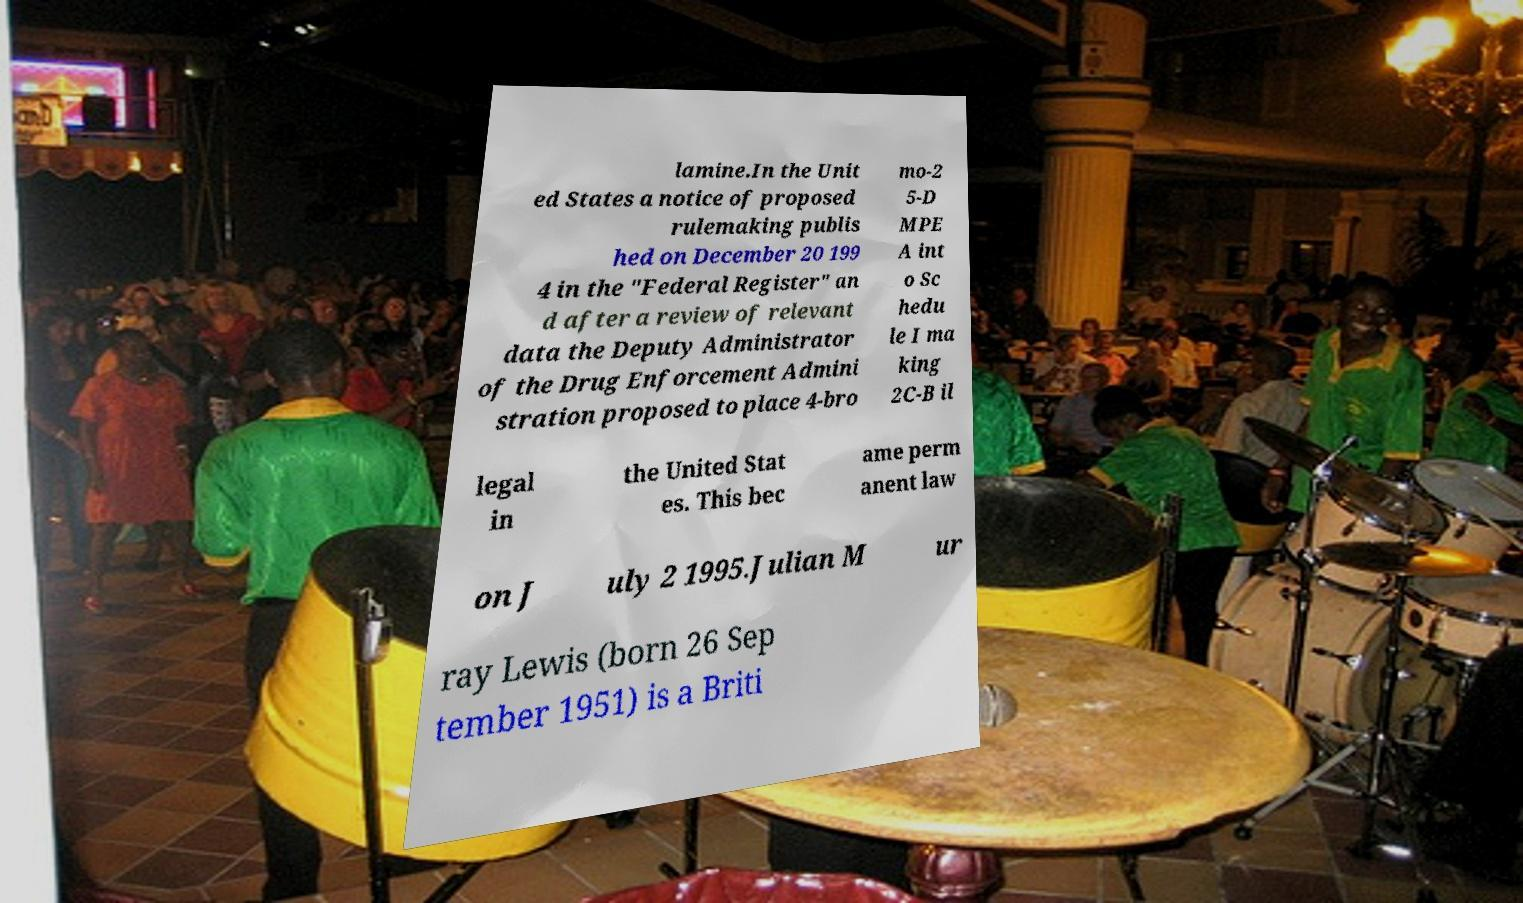Could you extract and type out the text from this image? lamine.In the Unit ed States a notice of proposed rulemaking publis hed on December 20 199 4 in the "Federal Register" an d after a review of relevant data the Deputy Administrator of the Drug Enforcement Admini stration proposed to place 4-bro mo-2 5-D MPE A int o Sc hedu le I ma king 2C-B il legal in the United Stat es. This bec ame perm anent law on J uly 2 1995.Julian M ur ray Lewis (born 26 Sep tember 1951) is a Briti 